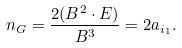<formula> <loc_0><loc_0><loc_500><loc_500>n _ { G } = \frac { 2 ( B ^ { 2 } \cdot E ) } { B ^ { 3 } } = 2 a _ { i _ { 1 } } .</formula> 